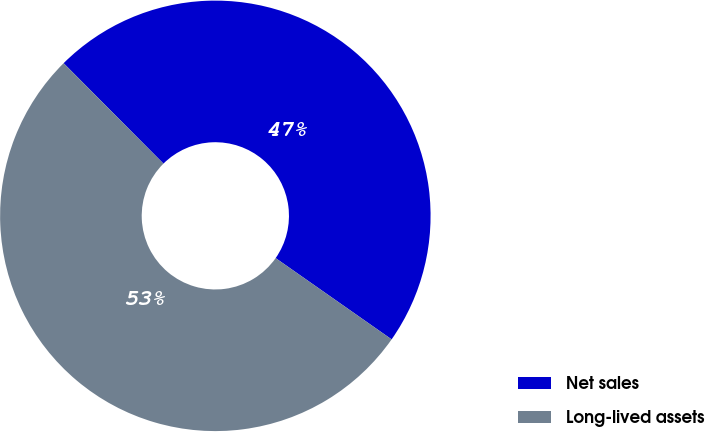Convert chart. <chart><loc_0><loc_0><loc_500><loc_500><pie_chart><fcel>Net sales<fcel>Long-lived assets<nl><fcel>47.18%<fcel>52.82%<nl></chart> 